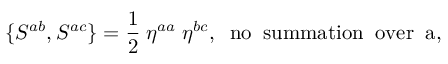<formula> <loc_0><loc_0><loc_500><loc_500>\{ S ^ { a b } , S ^ { a c } \} = \frac { 1 } { 2 } \, \eta ^ { a a } \, \eta ^ { b c } , \, n o \, s u m m a t i o n \, o v e r \, a ,</formula> 